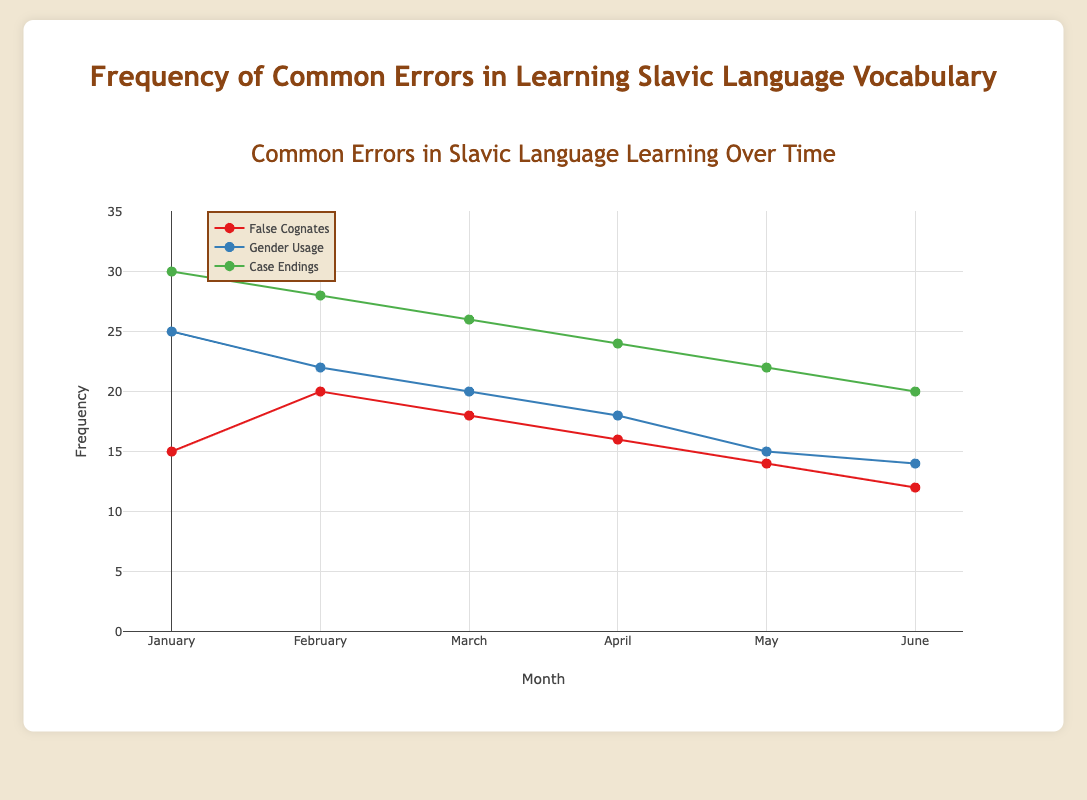Which error type has the highest frequency in January? By looking at the plot, we can see the point with the highest position on the y-axis for January. This corresponds to "Case Endings" with frequency 30.
Answer: Case Endings How does the frequency of 'False Cognates' change from January to June? From the plot, we can observe that the frequency of 'False Cognates' starts at 15 in January and decreases to 12 in June. The trend shows a general decline over the months.
Answer: Decreases Which month shows the highest frequency of 'Gender Usage' errors? By examining the plot points for 'Gender Usage', the highest y-value is found in January with a frequency of 25.
Answer: January How many errors were recorded for 'Case Endings' in May? The point representing 'Case Endings' in May can be observed on the plot and has a y-value of 22.
Answer: 22 Compare the frequency of 'False Cognates' and 'Gender Usage' in April. Which one is higher? In April, 'False Cognates' is at 16, and 'Gender Usage' is at 18. Therefore, 'Gender Usage' is higher.
Answer: Gender Usage What is the average frequency of 'Gender Usage' errors over the six months? The frequencies for 'Gender Usage' from January to June are 25, 22, 20, 18, 15, and 14. Summing these values gives 114, and dividing by 6 gives an average of 19.
Answer: 19 Between which months does 'Case Endings' show the highest rate of decrease in frequency? Observing the trend line for 'Case Endings', the steepest drop appears to be between January (30) and February (28), a difference of 2.
Answer: January to February What is the overall trend for 'False Cognates' throughout the months? The plot displays a decreasing trend in 'False Cognates' from January to June, with some fluctuations.
Answer: Decreasing What is the total frequency of common errors recorded in June across all types? Adding the frequencies for 'False Cognates' (12), 'Gender Usage' (14), and 'Case Endings' (20) recorded in June gives 46.
Answer: 46 